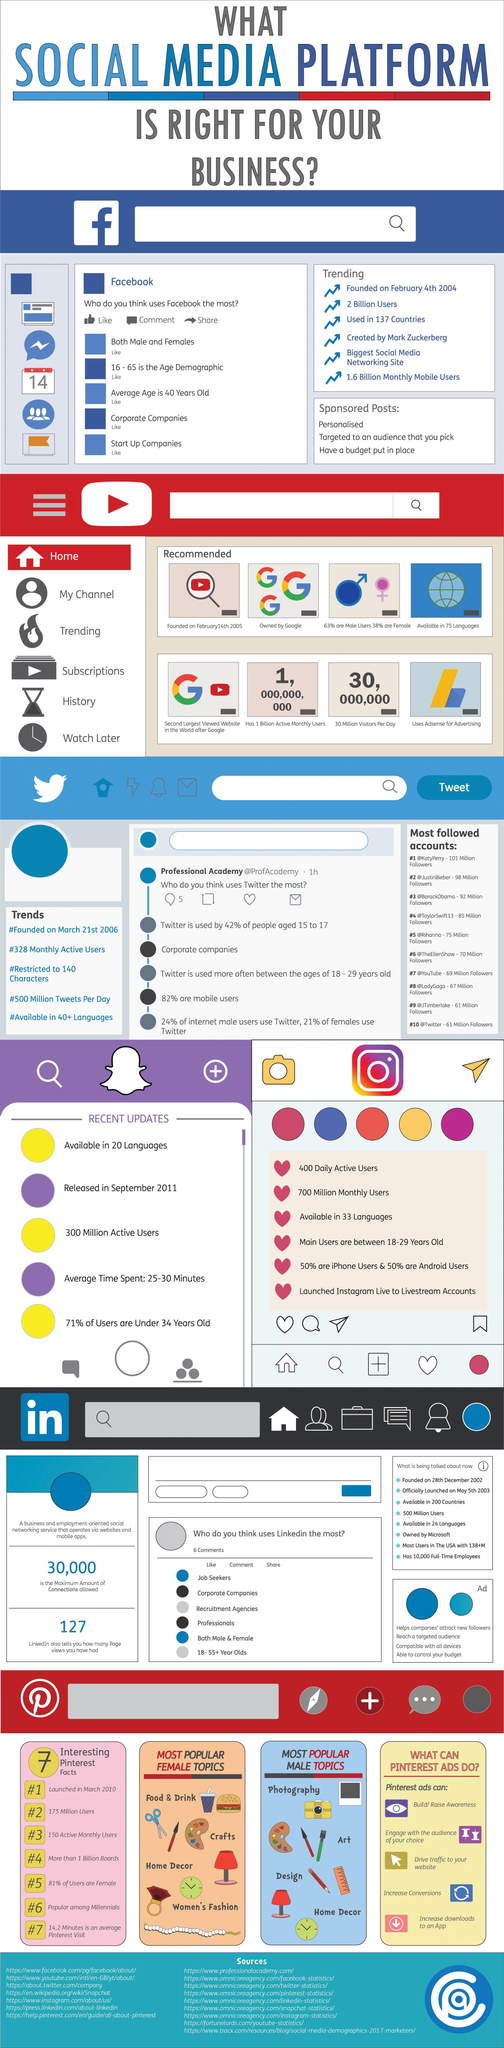What is the maximum amount of connections allowed?
Answer the question with a short phrase. 30,000 What is the number of most popular male topics? 10 What is the number of most popular female topics? 8 